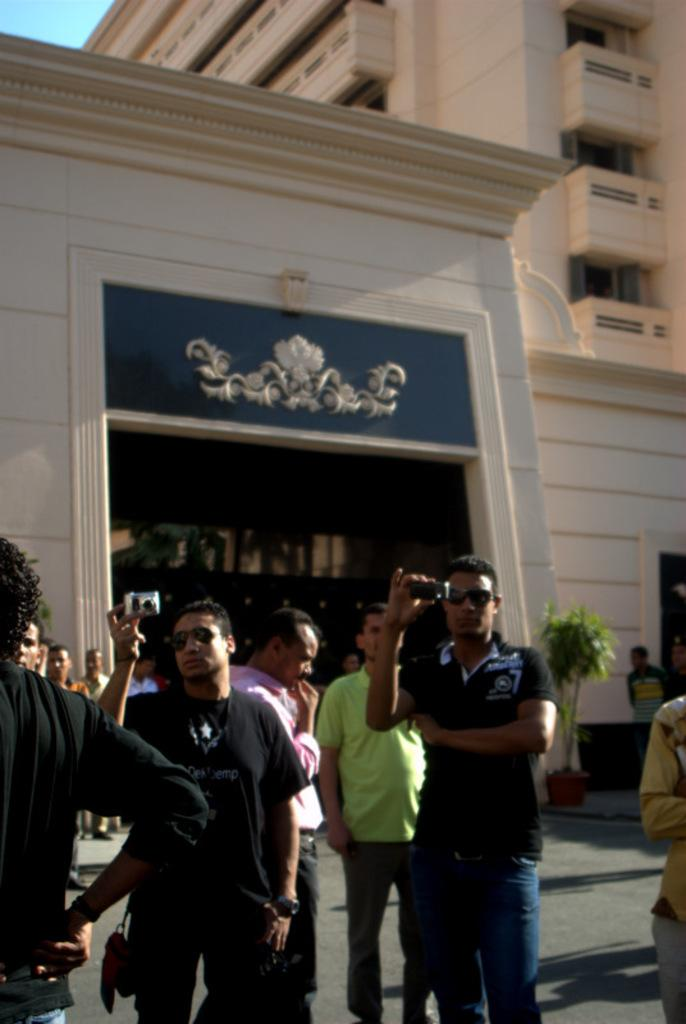What are the people in the image doing? The people in the image are standing and holding cameras in their hands. What can be seen in the background of the image? There is a building and trees in the background of the image. What type of yarn is being used by the jellyfish in the image? There are no jellyfish or yarn present in the image. How many boys can be seen in the image? The image does not specify the gender of the people, so it is not possible to determine the number of boys in the image. 